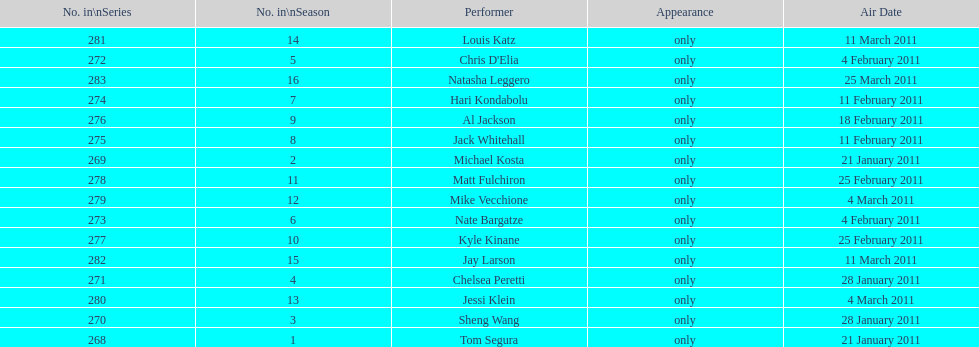How many different performers appeared during this season? 16. 